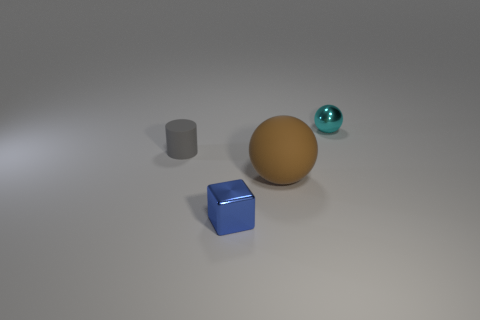Add 1 small brown metal objects. How many objects exist? 5 Subtract all cubes. How many objects are left? 3 Subtract all brown spheres. How many spheres are left? 1 Subtract all large blocks. Subtract all small metal blocks. How many objects are left? 3 Add 2 small spheres. How many small spheres are left? 3 Add 4 blue things. How many blue things exist? 5 Subtract 0 red balls. How many objects are left? 4 Subtract 1 spheres. How many spheres are left? 1 Subtract all yellow spheres. Subtract all purple cubes. How many spheres are left? 2 Subtract all cyan cylinders. How many brown spheres are left? 1 